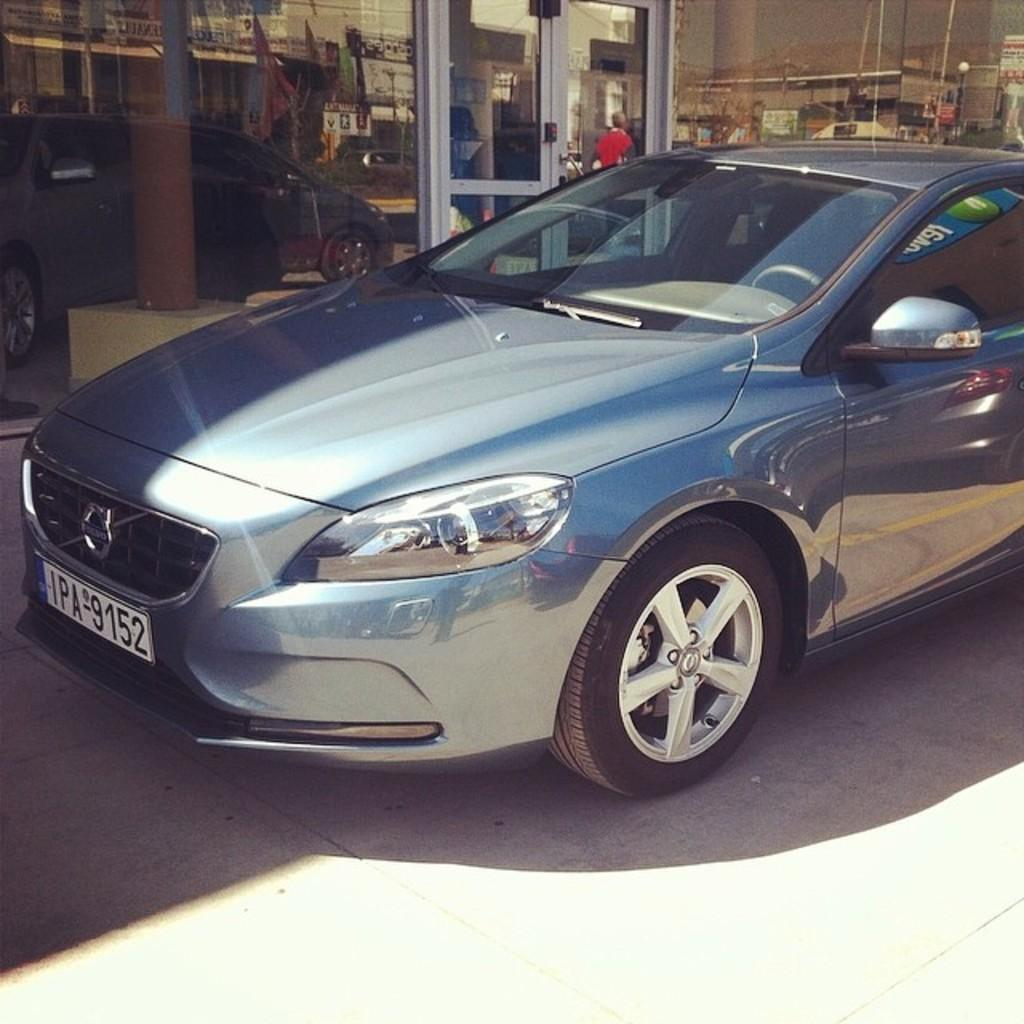What is on the road in the image? There is a car on the road in the image. What type of building can be seen in the image? There is a building with a glass wall in the image. What feature of the building is mentioned in the facts? The building has doors. How many leaves are on the car in the image? There are no leaves present on the car in the image. Can you see a skateboarder performing a trick near the building? There is no mention of a skateboarder or any tricks in the image. Is there a cork attached to the doors of the building? There is no mention of a cork in the image. 